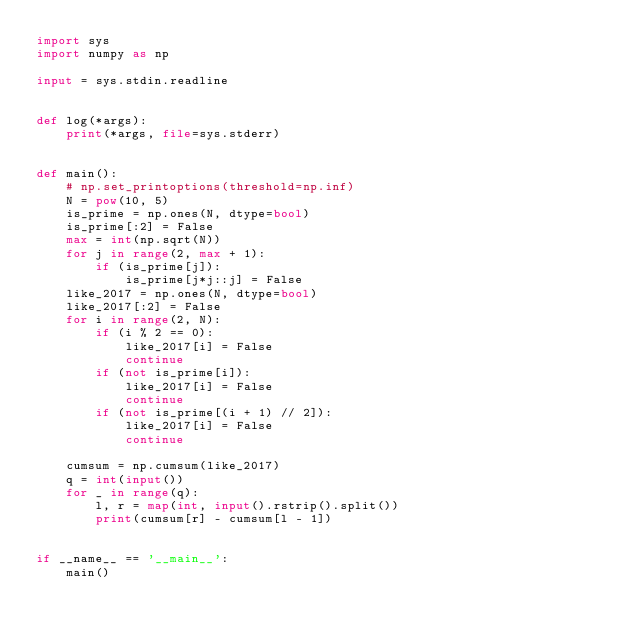Convert code to text. <code><loc_0><loc_0><loc_500><loc_500><_Python_>import sys
import numpy as np

input = sys.stdin.readline


def log(*args):
    print(*args, file=sys.stderr)


def main():
    # np.set_printoptions(threshold=np.inf)
    N = pow(10, 5)
    is_prime = np.ones(N, dtype=bool)
    is_prime[:2] = False
    max = int(np.sqrt(N))
    for j in range(2, max + 1):
        if (is_prime[j]):
            is_prime[j*j::j] = False
    like_2017 = np.ones(N, dtype=bool)
    like_2017[:2] = False
    for i in range(2, N):
        if (i % 2 == 0):
            like_2017[i] = False
            continue
        if (not is_prime[i]):
            like_2017[i] = False
            continue
        if (not is_prime[(i + 1) // 2]):
            like_2017[i] = False
            continue

    cumsum = np.cumsum(like_2017)
    q = int(input())
    for _ in range(q):
        l, r = map(int, input().rstrip().split())
        print(cumsum[r] - cumsum[l - 1])


if __name__ == '__main__':
    main()
</code> 